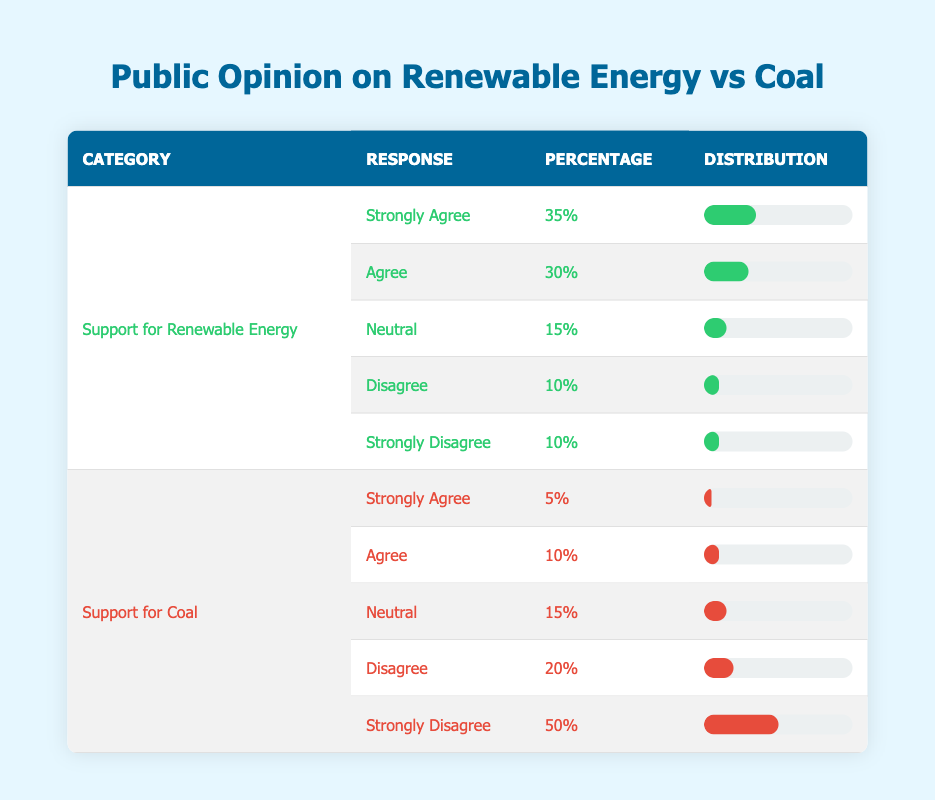What percentage of respondents strongly agree with supporting renewable energy? According to the table, 35% of respondents indicated they "Strongly Agree" with supporting renewable energy.
Answer: 35% What is the percentage of respondents who disagree with supporting coal? The table shows that 20% of respondents "Disagree" with supporting coal.
Answer: 20% What is the total percentage of people who agree (either strongly or somewhat) with renewable energy? To find this, add the percentages of "Strongly Agree" (35%) and "Agree" (30%) for renewable energy: 35 + 30 = 65%.
Answer: 65% What is the percentage difference between those who strongly disagree with coal and those who strongly agree with renewable energy? Strongly disagree with coal is 50%, and strongly agree with renewable energy is 35%. To find the difference, subtract 35 from 50: 50 - 35 = 15%.
Answer: 15% Is it true that more respondents support renewable energy than support coal? Yes, the combined support for renewable energy responses (35% + 30% = 65%) is greater than the support for coal (5% + 10% = 15%).
Answer: Yes What percentage of respondents is neutral about renewable energy? The table indicates that 15% of respondents are neutral regarding renewable energy.
Answer: 15% Calculate the average percentage of respondents who disagree or strongly disagree with renewable energy. The percentages for "Disagree" and "Strongly Disagree" for renewable energy are both 10%. Adding these gives 10 + 10 = 20%, and the average is 20% / 2 = 10%.
Answer: 10% What proportion of respondents supports coal in any form (agree, neutral, or disagree)? The percentages for supporting coal in any form are: "Agree" (10%), "Neutral" (15%), and "Disagree" (20%). Adding these gives 10 + 15 + 20 = 45%.
Answer: 45% 